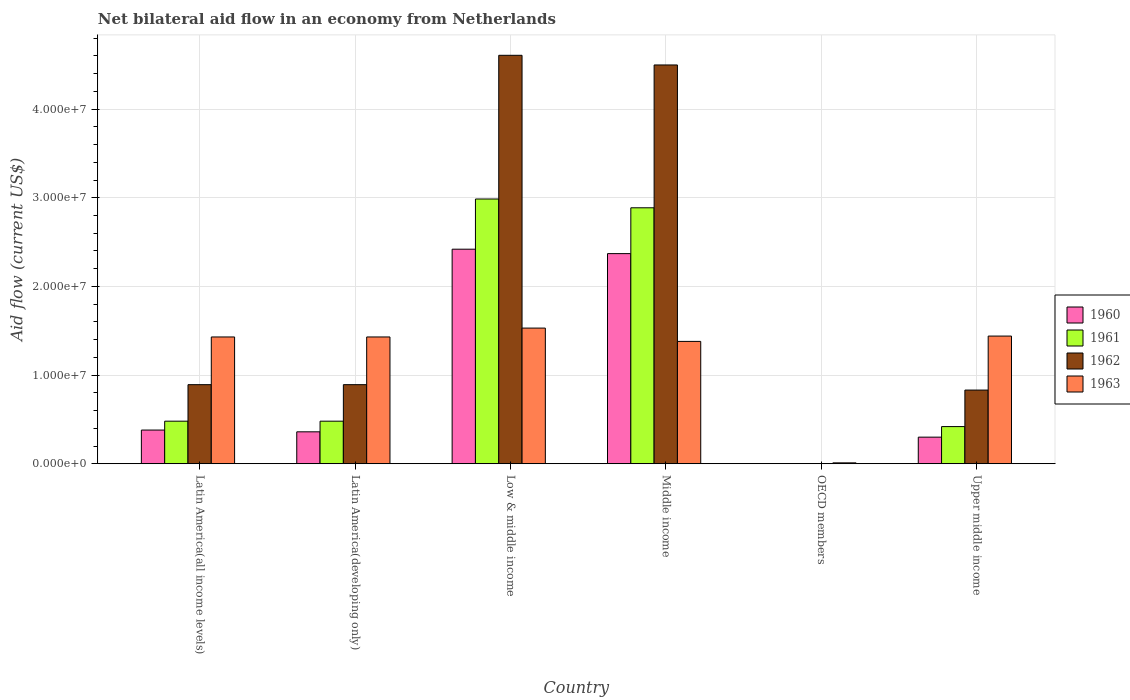Are the number of bars on each tick of the X-axis equal?
Your response must be concise. No. How many bars are there on the 6th tick from the right?
Offer a very short reply. 4. What is the label of the 6th group of bars from the left?
Your answer should be very brief. Upper middle income. What is the net bilateral aid flow in 1963 in Latin America(developing only)?
Your answer should be compact. 1.43e+07. Across all countries, what is the maximum net bilateral aid flow in 1963?
Your response must be concise. 1.53e+07. What is the total net bilateral aid flow in 1962 in the graph?
Offer a very short reply. 1.17e+08. What is the difference between the net bilateral aid flow in 1960 in Latin America(all income levels) and that in Middle income?
Your answer should be compact. -1.99e+07. What is the difference between the net bilateral aid flow in 1961 in Upper middle income and the net bilateral aid flow in 1963 in OECD members?
Provide a succinct answer. 4.09e+06. What is the average net bilateral aid flow in 1961 per country?
Offer a terse response. 1.21e+07. What is the difference between the net bilateral aid flow of/in 1963 and net bilateral aid flow of/in 1961 in Middle income?
Offer a terse response. -1.51e+07. In how many countries, is the net bilateral aid flow in 1963 greater than 16000000 US$?
Ensure brevity in your answer.  0. What is the ratio of the net bilateral aid flow in 1961 in Latin America(all income levels) to that in Upper middle income?
Ensure brevity in your answer.  1.15. What is the difference between the highest and the lowest net bilateral aid flow in 1961?
Provide a succinct answer. 2.99e+07. Is it the case that in every country, the sum of the net bilateral aid flow in 1961 and net bilateral aid flow in 1960 is greater than the net bilateral aid flow in 1963?
Keep it short and to the point. No. Does the graph contain any zero values?
Offer a terse response. Yes. Does the graph contain grids?
Your response must be concise. Yes. Where does the legend appear in the graph?
Your answer should be very brief. Center right. What is the title of the graph?
Make the answer very short. Net bilateral aid flow in an economy from Netherlands. Does "1967" appear as one of the legend labels in the graph?
Provide a succinct answer. No. What is the label or title of the X-axis?
Your answer should be very brief. Country. What is the label or title of the Y-axis?
Provide a succinct answer. Aid flow (current US$). What is the Aid flow (current US$) in 1960 in Latin America(all income levels)?
Give a very brief answer. 3.80e+06. What is the Aid flow (current US$) of 1961 in Latin America(all income levels)?
Give a very brief answer. 4.80e+06. What is the Aid flow (current US$) of 1962 in Latin America(all income levels)?
Make the answer very short. 8.92e+06. What is the Aid flow (current US$) in 1963 in Latin America(all income levels)?
Make the answer very short. 1.43e+07. What is the Aid flow (current US$) in 1960 in Latin America(developing only)?
Provide a short and direct response. 3.60e+06. What is the Aid flow (current US$) of 1961 in Latin America(developing only)?
Your response must be concise. 4.80e+06. What is the Aid flow (current US$) of 1962 in Latin America(developing only)?
Provide a succinct answer. 8.92e+06. What is the Aid flow (current US$) of 1963 in Latin America(developing only)?
Your answer should be very brief. 1.43e+07. What is the Aid flow (current US$) of 1960 in Low & middle income?
Provide a short and direct response. 2.42e+07. What is the Aid flow (current US$) in 1961 in Low & middle income?
Give a very brief answer. 2.99e+07. What is the Aid flow (current US$) of 1962 in Low & middle income?
Your answer should be very brief. 4.61e+07. What is the Aid flow (current US$) in 1963 in Low & middle income?
Your answer should be compact. 1.53e+07. What is the Aid flow (current US$) of 1960 in Middle income?
Make the answer very short. 2.37e+07. What is the Aid flow (current US$) in 1961 in Middle income?
Your response must be concise. 2.89e+07. What is the Aid flow (current US$) in 1962 in Middle income?
Your answer should be compact. 4.50e+07. What is the Aid flow (current US$) in 1963 in Middle income?
Your response must be concise. 1.38e+07. What is the Aid flow (current US$) of 1960 in OECD members?
Your answer should be very brief. 0. What is the Aid flow (current US$) of 1963 in OECD members?
Make the answer very short. 1.00e+05. What is the Aid flow (current US$) in 1960 in Upper middle income?
Keep it short and to the point. 3.00e+06. What is the Aid flow (current US$) of 1961 in Upper middle income?
Make the answer very short. 4.19e+06. What is the Aid flow (current US$) of 1962 in Upper middle income?
Provide a succinct answer. 8.31e+06. What is the Aid flow (current US$) of 1963 in Upper middle income?
Keep it short and to the point. 1.44e+07. Across all countries, what is the maximum Aid flow (current US$) in 1960?
Offer a very short reply. 2.42e+07. Across all countries, what is the maximum Aid flow (current US$) in 1961?
Your answer should be very brief. 2.99e+07. Across all countries, what is the maximum Aid flow (current US$) in 1962?
Ensure brevity in your answer.  4.61e+07. Across all countries, what is the maximum Aid flow (current US$) in 1963?
Your response must be concise. 1.53e+07. Across all countries, what is the minimum Aid flow (current US$) in 1960?
Your answer should be very brief. 0. Across all countries, what is the minimum Aid flow (current US$) of 1961?
Give a very brief answer. 0. Across all countries, what is the minimum Aid flow (current US$) of 1962?
Your response must be concise. 0. Across all countries, what is the minimum Aid flow (current US$) of 1963?
Offer a terse response. 1.00e+05. What is the total Aid flow (current US$) of 1960 in the graph?
Offer a terse response. 5.83e+07. What is the total Aid flow (current US$) in 1961 in the graph?
Keep it short and to the point. 7.25e+07. What is the total Aid flow (current US$) in 1962 in the graph?
Your answer should be very brief. 1.17e+08. What is the total Aid flow (current US$) in 1963 in the graph?
Offer a very short reply. 7.22e+07. What is the difference between the Aid flow (current US$) of 1961 in Latin America(all income levels) and that in Latin America(developing only)?
Provide a short and direct response. 0. What is the difference between the Aid flow (current US$) in 1963 in Latin America(all income levels) and that in Latin America(developing only)?
Offer a very short reply. 0. What is the difference between the Aid flow (current US$) in 1960 in Latin America(all income levels) and that in Low & middle income?
Make the answer very short. -2.04e+07. What is the difference between the Aid flow (current US$) of 1961 in Latin America(all income levels) and that in Low & middle income?
Offer a terse response. -2.51e+07. What is the difference between the Aid flow (current US$) in 1962 in Latin America(all income levels) and that in Low & middle income?
Offer a very short reply. -3.72e+07. What is the difference between the Aid flow (current US$) of 1960 in Latin America(all income levels) and that in Middle income?
Provide a short and direct response. -1.99e+07. What is the difference between the Aid flow (current US$) in 1961 in Latin America(all income levels) and that in Middle income?
Your response must be concise. -2.41e+07. What is the difference between the Aid flow (current US$) of 1962 in Latin America(all income levels) and that in Middle income?
Provide a short and direct response. -3.61e+07. What is the difference between the Aid flow (current US$) in 1963 in Latin America(all income levels) and that in OECD members?
Keep it short and to the point. 1.42e+07. What is the difference between the Aid flow (current US$) of 1963 in Latin America(all income levels) and that in Upper middle income?
Make the answer very short. -1.00e+05. What is the difference between the Aid flow (current US$) in 1960 in Latin America(developing only) and that in Low & middle income?
Give a very brief answer. -2.06e+07. What is the difference between the Aid flow (current US$) in 1961 in Latin America(developing only) and that in Low & middle income?
Provide a short and direct response. -2.51e+07. What is the difference between the Aid flow (current US$) in 1962 in Latin America(developing only) and that in Low & middle income?
Provide a short and direct response. -3.72e+07. What is the difference between the Aid flow (current US$) of 1960 in Latin America(developing only) and that in Middle income?
Your answer should be very brief. -2.01e+07. What is the difference between the Aid flow (current US$) in 1961 in Latin America(developing only) and that in Middle income?
Make the answer very short. -2.41e+07. What is the difference between the Aid flow (current US$) in 1962 in Latin America(developing only) and that in Middle income?
Offer a very short reply. -3.61e+07. What is the difference between the Aid flow (current US$) in 1963 in Latin America(developing only) and that in OECD members?
Make the answer very short. 1.42e+07. What is the difference between the Aid flow (current US$) in 1963 in Latin America(developing only) and that in Upper middle income?
Provide a short and direct response. -1.00e+05. What is the difference between the Aid flow (current US$) in 1961 in Low & middle income and that in Middle income?
Your answer should be compact. 9.90e+05. What is the difference between the Aid flow (current US$) in 1962 in Low & middle income and that in Middle income?
Offer a very short reply. 1.09e+06. What is the difference between the Aid flow (current US$) of 1963 in Low & middle income and that in Middle income?
Offer a terse response. 1.50e+06. What is the difference between the Aid flow (current US$) of 1963 in Low & middle income and that in OECD members?
Ensure brevity in your answer.  1.52e+07. What is the difference between the Aid flow (current US$) of 1960 in Low & middle income and that in Upper middle income?
Provide a succinct answer. 2.12e+07. What is the difference between the Aid flow (current US$) of 1961 in Low & middle income and that in Upper middle income?
Make the answer very short. 2.57e+07. What is the difference between the Aid flow (current US$) in 1962 in Low & middle income and that in Upper middle income?
Make the answer very short. 3.78e+07. What is the difference between the Aid flow (current US$) in 1963 in Low & middle income and that in Upper middle income?
Your answer should be compact. 9.00e+05. What is the difference between the Aid flow (current US$) in 1963 in Middle income and that in OECD members?
Your answer should be very brief. 1.37e+07. What is the difference between the Aid flow (current US$) of 1960 in Middle income and that in Upper middle income?
Ensure brevity in your answer.  2.07e+07. What is the difference between the Aid flow (current US$) in 1961 in Middle income and that in Upper middle income?
Your answer should be compact. 2.47e+07. What is the difference between the Aid flow (current US$) of 1962 in Middle income and that in Upper middle income?
Offer a terse response. 3.67e+07. What is the difference between the Aid flow (current US$) in 1963 in Middle income and that in Upper middle income?
Ensure brevity in your answer.  -6.00e+05. What is the difference between the Aid flow (current US$) of 1963 in OECD members and that in Upper middle income?
Ensure brevity in your answer.  -1.43e+07. What is the difference between the Aid flow (current US$) in 1960 in Latin America(all income levels) and the Aid flow (current US$) in 1961 in Latin America(developing only)?
Give a very brief answer. -1.00e+06. What is the difference between the Aid flow (current US$) in 1960 in Latin America(all income levels) and the Aid flow (current US$) in 1962 in Latin America(developing only)?
Provide a short and direct response. -5.12e+06. What is the difference between the Aid flow (current US$) of 1960 in Latin America(all income levels) and the Aid flow (current US$) of 1963 in Latin America(developing only)?
Ensure brevity in your answer.  -1.05e+07. What is the difference between the Aid flow (current US$) of 1961 in Latin America(all income levels) and the Aid flow (current US$) of 1962 in Latin America(developing only)?
Your answer should be compact. -4.12e+06. What is the difference between the Aid flow (current US$) of 1961 in Latin America(all income levels) and the Aid flow (current US$) of 1963 in Latin America(developing only)?
Your answer should be very brief. -9.50e+06. What is the difference between the Aid flow (current US$) in 1962 in Latin America(all income levels) and the Aid flow (current US$) in 1963 in Latin America(developing only)?
Give a very brief answer. -5.38e+06. What is the difference between the Aid flow (current US$) of 1960 in Latin America(all income levels) and the Aid flow (current US$) of 1961 in Low & middle income?
Give a very brief answer. -2.61e+07. What is the difference between the Aid flow (current US$) in 1960 in Latin America(all income levels) and the Aid flow (current US$) in 1962 in Low & middle income?
Provide a short and direct response. -4.23e+07. What is the difference between the Aid flow (current US$) in 1960 in Latin America(all income levels) and the Aid flow (current US$) in 1963 in Low & middle income?
Provide a succinct answer. -1.15e+07. What is the difference between the Aid flow (current US$) of 1961 in Latin America(all income levels) and the Aid flow (current US$) of 1962 in Low & middle income?
Give a very brief answer. -4.13e+07. What is the difference between the Aid flow (current US$) of 1961 in Latin America(all income levels) and the Aid flow (current US$) of 1963 in Low & middle income?
Provide a short and direct response. -1.05e+07. What is the difference between the Aid flow (current US$) of 1962 in Latin America(all income levels) and the Aid flow (current US$) of 1963 in Low & middle income?
Provide a succinct answer. -6.38e+06. What is the difference between the Aid flow (current US$) of 1960 in Latin America(all income levels) and the Aid flow (current US$) of 1961 in Middle income?
Offer a terse response. -2.51e+07. What is the difference between the Aid flow (current US$) of 1960 in Latin America(all income levels) and the Aid flow (current US$) of 1962 in Middle income?
Offer a terse response. -4.12e+07. What is the difference between the Aid flow (current US$) of 1960 in Latin America(all income levels) and the Aid flow (current US$) of 1963 in Middle income?
Offer a terse response. -1.00e+07. What is the difference between the Aid flow (current US$) in 1961 in Latin America(all income levels) and the Aid flow (current US$) in 1962 in Middle income?
Your response must be concise. -4.02e+07. What is the difference between the Aid flow (current US$) in 1961 in Latin America(all income levels) and the Aid flow (current US$) in 1963 in Middle income?
Provide a succinct answer. -9.00e+06. What is the difference between the Aid flow (current US$) of 1962 in Latin America(all income levels) and the Aid flow (current US$) of 1963 in Middle income?
Keep it short and to the point. -4.88e+06. What is the difference between the Aid flow (current US$) in 1960 in Latin America(all income levels) and the Aid flow (current US$) in 1963 in OECD members?
Offer a terse response. 3.70e+06. What is the difference between the Aid flow (current US$) in 1961 in Latin America(all income levels) and the Aid flow (current US$) in 1963 in OECD members?
Offer a terse response. 4.70e+06. What is the difference between the Aid flow (current US$) in 1962 in Latin America(all income levels) and the Aid flow (current US$) in 1963 in OECD members?
Your response must be concise. 8.82e+06. What is the difference between the Aid flow (current US$) in 1960 in Latin America(all income levels) and the Aid flow (current US$) in 1961 in Upper middle income?
Keep it short and to the point. -3.90e+05. What is the difference between the Aid flow (current US$) of 1960 in Latin America(all income levels) and the Aid flow (current US$) of 1962 in Upper middle income?
Provide a succinct answer. -4.51e+06. What is the difference between the Aid flow (current US$) in 1960 in Latin America(all income levels) and the Aid flow (current US$) in 1963 in Upper middle income?
Your response must be concise. -1.06e+07. What is the difference between the Aid flow (current US$) of 1961 in Latin America(all income levels) and the Aid flow (current US$) of 1962 in Upper middle income?
Your answer should be very brief. -3.51e+06. What is the difference between the Aid flow (current US$) in 1961 in Latin America(all income levels) and the Aid flow (current US$) in 1963 in Upper middle income?
Make the answer very short. -9.60e+06. What is the difference between the Aid flow (current US$) in 1962 in Latin America(all income levels) and the Aid flow (current US$) in 1963 in Upper middle income?
Provide a succinct answer. -5.48e+06. What is the difference between the Aid flow (current US$) in 1960 in Latin America(developing only) and the Aid flow (current US$) in 1961 in Low & middle income?
Ensure brevity in your answer.  -2.63e+07. What is the difference between the Aid flow (current US$) of 1960 in Latin America(developing only) and the Aid flow (current US$) of 1962 in Low & middle income?
Make the answer very short. -4.25e+07. What is the difference between the Aid flow (current US$) in 1960 in Latin America(developing only) and the Aid flow (current US$) in 1963 in Low & middle income?
Offer a very short reply. -1.17e+07. What is the difference between the Aid flow (current US$) in 1961 in Latin America(developing only) and the Aid flow (current US$) in 1962 in Low & middle income?
Offer a very short reply. -4.13e+07. What is the difference between the Aid flow (current US$) of 1961 in Latin America(developing only) and the Aid flow (current US$) of 1963 in Low & middle income?
Ensure brevity in your answer.  -1.05e+07. What is the difference between the Aid flow (current US$) in 1962 in Latin America(developing only) and the Aid flow (current US$) in 1963 in Low & middle income?
Your response must be concise. -6.38e+06. What is the difference between the Aid flow (current US$) of 1960 in Latin America(developing only) and the Aid flow (current US$) of 1961 in Middle income?
Keep it short and to the point. -2.53e+07. What is the difference between the Aid flow (current US$) of 1960 in Latin America(developing only) and the Aid flow (current US$) of 1962 in Middle income?
Ensure brevity in your answer.  -4.14e+07. What is the difference between the Aid flow (current US$) of 1960 in Latin America(developing only) and the Aid flow (current US$) of 1963 in Middle income?
Provide a succinct answer. -1.02e+07. What is the difference between the Aid flow (current US$) in 1961 in Latin America(developing only) and the Aid flow (current US$) in 1962 in Middle income?
Give a very brief answer. -4.02e+07. What is the difference between the Aid flow (current US$) in 1961 in Latin America(developing only) and the Aid flow (current US$) in 1963 in Middle income?
Your response must be concise. -9.00e+06. What is the difference between the Aid flow (current US$) in 1962 in Latin America(developing only) and the Aid flow (current US$) in 1963 in Middle income?
Offer a very short reply. -4.88e+06. What is the difference between the Aid flow (current US$) in 1960 in Latin America(developing only) and the Aid flow (current US$) in 1963 in OECD members?
Your answer should be very brief. 3.50e+06. What is the difference between the Aid flow (current US$) in 1961 in Latin America(developing only) and the Aid flow (current US$) in 1963 in OECD members?
Your answer should be very brief. 4.70e+06. What is the difference between the Aid flow (current US$) of 1962 in Latin America(developing only) and the Aid flow (current US$) of 1963 in OECD members?
Keep it short and to the point. 8.82e+06. What is the difference between the Aid flow (current US$) of 1960 in Latin America(developing only) and the Aid flow (current US$) of 1961 in Upper middle income?
Your answer should be very brief. -5.90e+05. What is the difference between the Aid flow (current US$) of 1960 in Latin America(developing only) and the Aid flow (current US$) of 1962 in Upper middle income?
Provide a succinct answer. -4.71e+06. What is the difference between the Aid flow (current US$) of 1960 in Latin America(developing only) and the Aid flow (current US$) of 1963 in Upper middle income?
Your answer should be compact. -1.08e+07. What is the difference between the Aid flow (current US$) of 1961 in Latin America(developing only) and the Aid flow (current US$) of 1962 in Upper middle income?
Give a very brief answer. -3.51e+06. What is the difference between the Aid flow (current US$) of 1961 in Latin America(developing only) and the Aid flow (current US$) of 1963 in Upper middle income?
Ensure brevity in your answer.  -9.60e+06. What is the difference between the Aid flow (current US$) in 1962 in Latin America(developing only) and the Aid flow (current US$) in 1963 in Upper middle income?
Offer a very short reply. -5.48e+06. What is the difference between the Aid flow (current US$) of 1960 in Low & middle income and the Aid flow (current US$) of 1961 in Middle income?
Make the answer very short. -4.67e+06. What is the difference between the Aid flow (current US$) of 1960 in Low & middle income and the Aid flow (current US$) of 1962 in Middle income?
Make the answer very short. -2.08e+07. What is the difference between the Aid flow (current US$) of 1960 in Low & middle income and the Aid flow (current US$) of 1963 in Middle income?
Provide a short and direct response. 1.04e+07. What is the difference between the Aid flow (current US$) of 1961 in Low & middle income and the Aid flow (current US$) of 1962 in Middle income?
Provide a succinct answer. -1.51e+07. What is the difference between the Aid flow (current US$) in 1961 in Low & middle income and the Aid flow (current US$) in 1963 in Middle income?
Your answer should be very brief. 1.61e+07. What is the difference between the Aid flow (current US$) of 1962 in Low & middle income and the Aid flow (current US$) of 1963 in Middle income?
Make the answer very short. 3.23e+07. What is the difference between the Aid flow (current US$) of 1960 in Low & middle income and the Aid flow (current US$) of 1963 in OECD members?
Provide a succinct answer. 2.41e+07. What is the difference between the Aid flow (current US$) in 1961 in Low & middle income and the Aid flow (current US$) in 1963 in OECD members?
Provide a succinct answer. 2.98e+07. What is the difference between the Aid flow (current US$) in 1962 in Low & middle income and the Aid flow (current US$) in 1963 in OECD members?
Keep it short and to the point. 4.60e+07. What is the difference between the Aid flow (current US$) in 1960 in Low & middle income and the Aid flow (current US$) in 1961 in Upper middle income?
Ensure brevity in your answer.  2.00e+07. What is the difference between the Aid flow (current US$) of 1960 in Low & middle income and the Aid flow (current US$) of 1962 in Upper middle income?
Keep it short and to the point. 1.59e+07. What is the difference between the Aid flow (current US$) of 1960 in Low & middle income and the Aid flow (current US$) of 1963 in Upper middle income?
Offer a terse response. 9.80e+06. What is the difference between the Aid flow (current US$) of 1961 in Low & middle income and the Aid flow (current US$) of 1962 in Upper middle income?
Keep it short and to the point. 2.16e+07. What is the difference between the Aid flow (current US$) in 1961 in Low & middle income and the Aid flow (current US$) in 1963 in Upper middle income?
Your answer should be very brief. 1.55e+07. What is the difference between the Aid flow (current US$) of 1962 in Low & middle income and the Aid flow (current US$) of 1963 in Upper middle income?
Your answer should be compact. 3.17e+07. What is the difference between the Aid flow (current US$) in 1960 in Middle income and the Aid flow (current US$) in 1963 in OECD members?
Offer a very short reply. 2.36e+07. What is the difference between the Aid flow (current US$) of 1961 in Middle income and the Aid flow (current US$) of 1963 in OECD members?
Provide a short and direct response. 2.88e+07. What is the difference between the Aid flow (current US$) of 1962 in Middle income and the Aid flow (current US$) of 1963 in OECD members?
Make the answer very short. 4.49e+07. What is the difference between the Aid flow (current US$) of 1960 in Middle income and the Aid flow (current US$) of 1961 in Upper middle income?
Give a very brief answer. 1.95e+07. What is the difference between the Aid flow (current US$) in 1960 in Middle income and the Aid flow (current US$) in 1962 in Upper middle income?
Provide a short and direct response. 1.54e+07. What is the difference between the Aid flow (current US$) of 1960 in Middle income and the Aid flow (current US$) of 1963 in Upper middle income?
Provide a short and direct response. 9.30e+06. What is the difference between the Aid flow (current US$) in 1961 in Middle income and the Aid flow (current US$) in 1962 in Upper middle income?
Make the answer very short. 2.06e+07. What is the difference between the Aid flow (current US$) of 1961 in Middle income and the Aid flow (current US$) of 1963 in Upper middle income?
Provide a succinct answer. 1.45e+07. What is the difference between the Aid flow (current US$) of 1962 in Middle income and the Aid flow (current US$) of 1963 in Upper middle income?
Offer a very short reply. 3.06e+07. What is the average Aid flow (current US$) of 1960 per country?
Your answer should be very brief. 9.72e+06. What is the average Aid flow (current US$) of 1961 per country?
Your response must be concise. 1.21e+07. What is the average Aid flow (current US$) of 1962 per country?
Give a very brief answer. 1.95e+07. What is the average Aid flow (current US$) in 1963 per country?
Offer a terse response. 1.20e+07. What is the difference between the Aid flow (current US$) in 1960 and Aid flow (current US$) in 1961 in Latin America(all income levels)?
Offer a terse response. -1.00e+06. What is the difference between the Aid flow (current US$) in 1960 and Aid flow (current US$) in 1962 in Latin America(all income levels)?
Provide a short and direct response. -5.12e+06. What is the difference between the Aid flow (current US$) of 1960 and Aid flow (current US$) of 1963 in Latin America(all income levels)?
Your answer should be compact. -1.05e+07. What is the difference between the Aid flow (current US$) in 1961 and Aid flow (current US$) in 1962 in Latin America(all income levels)?
Provide a succinct answer. -4.12e+06. What is the difference between the Aid flow (current US$) in 1961 and Aid flow (current US$) in 1963 in Latin America(all income levels)?
Provide a short and direct response. -9.50e+06. What is the difference between the Aid flow (current US$) of 1962 and Aid flow (current US$) of 1963 in Latin America(all income levels)?
Ensure brevity in your answer.  -5.38e+06. What is the difference between the Aid flow (current US$) of 1960 and Aid flow (current US$) of 1961 in Latin America(developing only)?
Ensure brevity in your answer.  -1.20e+06. What is the difference between the Aid flow (current US$) of 1960 and Aid flow (current US$) of 1962 in Latin America(developing only)?
Offer a very short reply. -5.32e+06. What is the difference between the Aid flow (current US$) in 1960 and Aid flow (current US$) in 1963 in Latin America(developing only)?
Give a very brief answer. -1.07e+07. What is the difference between the Aid flow (current US$) in 1961 and Aid flow (current US$) in 1962 in Latin America(developing only)?
Ensure brevity in your answer.  -4.12e+06. What is the difference between the Aid flow (current US$) in 1961 and Aid flow (current US$) in 1963 in Latin America(developing only)?
Offer a terse response. -9.50e+06. What is the difference between the Aid flow (current US$) of 1962 and Aid flow (current US$) of 1963 in Latin America(developing only)?
Offer a very short reply. -5.38e+06. What is the difference between the Aid flow (current US$) in 1960 and Aid flow (current US$) in 1961 in Low & middle income?
Ensure brevity in your answer.  -5.66e+06. What is the difference between the Aid flow (current US$) in 1960 and Aid flow (current US$) in 1962 in Low & middle income?
Your answer should be compact. -2.19e+07. What is the difference between the Aid flow (current US$) in 1960 and Aid flow (current US$) in 1963 in Low & middle income?
Make the answer very short. 8.90e+06. What is the difference between the Aid flow (current US$) in 1961 and Aid flow (current US$) in 1962 in Low & middle income?
Your answer should be very brief. -1.62e+07. What is the difference between the Aid flow (current US$) in 1961 and Aid flow (current US$) in 1963 in Low & middle income?
Your answer should be very brief. 1.46e+07. What is the difference between the Aid flow (current US$) of 1962 and Aid flow (current US$) of 1963 in Low & middle income?
Ensure brevity in your answer.  3.08e+07. What is the difference between the Aid flow (current US$) of 1960 and Aid flow (current US$) of 1961 in Middle income?
Offer a terse response. -5.17e+06. What is the difference between the Aid flow (current US$) of 1960 and Aid flow (current US$) of 1962 in Middle income?
Your answer should be compact. -2.13e+07. What is the difference between the Aid flow (current US$) in 1960 and Aid flow (current US$) in 1963 in Middle income?
Your answer should be very brief. 9.90e+06. What is the difference between the Aid flow (current US$) in 1961 and Aid flow (current US$) in 1962 in Middle income?
Provide a succinct answer. -1.61e+07. What is the difference between the Aid flow (current US$) of 1961 and Aid flow (current US$) of 1963 in Middle income?
Offer a terse response. 1.51e+07. What is the difference between the Aid flow (current US$) in 1962 and Aid flow (current US$) in 1963 in Middle income?
Your answer should be compact. 3.12e+07. What is the difference between the Aid flow (current US$) in 1960 and Aid flow (current US$) in 1961 in Upper middle income?
Offer a terse response. -1.19e+06. What is the difference between the Aid flow (current US$) in 1960 and Aid flow (current US$) in 1962 in Upper middle income?
Keep it short and to the point. -5.31e+06. What is the difference between the Aid flow (current US$) of 1960 and Aid flow (current US$) of 1963 in Upper middle income?
Provide a short and direct response. -1.14e+07. What is the difference between the Aid flow (current US$) of 1961 and Aid flow (current US$) of 1962 in Upper middle income?
Offer a very short reply. -4.12e+06. What is the difference between the Aid flow (current US$) in 1961 and Aid flow (current US$) in 1963 in Upper middle income?
Offer a very short reply. -1.02e+07. What is the difference between the Aid flow (current US$) of 1962 and Aid flow (current US$) of 1963 in Upper middle income?
Offer a very short reply. -6.09e+06. What is the ratio of the Aid flow (current US$) of 1960 in Latin America(all income levels) to that in Latin America(developing only)?
Your answer should be compact. 1.06. What is the ratio of the Aid flow (current US$) in 1961 in Latin America(all income levels) to that in Latin America(developing only)?
Provide a short and direct response. 1. What is the ratio of the Aid flow (current US$) in 1962 in Latin America(all income levels) to that in Latin America(developing only)?
Your response must be concise. 1. What is the ratio of the Aid flow (current US$) of 1960 in Latin America(all income levels) to that in Low & middle income?
Give a very brief answer. 0.16. What is the ratio of the Aid flow (current US$) in 1961 in Latin America(all income levels) to that in Low & middle income?
Keep it short and to the point. 0.16. What is the ratio of the Aid flow (current US$) of 1962 in Latin America(all income levels) to that in Low & middle income?
Your response must be concise. 0.19. What is the ratio of the Aid flow (current US$) in 1963 in Latin America(all income levels) to that in Low & middle income?
Offer a very short reply. 0.93. What is the ratio of the Aid flow (current US$) in 1960 in Latin America(all income levels) to that in Middle income?
Provide a short and direct response. 0.16. What is the ratio of the Aid flow (current US$) in 1961 in Latin America(all income levels) to that in Middle income?
Your answer should be very brief. 0.17. What is the ratio of the Aid flow (current US$) of 1962 in Latin America(all income levels) to that in Middle income?
Make the answer very short. 0.2. What is the ratio of the Aid flow (current US$) in 1963 in Latin America(all income levels) to that in Middle income?
Give a very brief answer. 1.04. What is the ratio of the Aid flow (current US$) in 1963 in Latin America(all income levels) to that in OECD members?
Provide a succinct answer. 143. What is the ratio of the Aid flow (current US$) in 1960 in Latin America(all income levels) to that in Upper middle income?
Offer a very short reply. 1.27. What is the ratio of the Aid flow (current US$) of 1961 in Latin America(all income levels) to that in Upper middle income?
Give a very brief answer. 1.15. What is the ratio of the Aid flow (current US$) of 1962 in Latin America(all income levels) to that in Upper middle income?
Your answer should be very brief. 1.07. What is the ratio of the Aid flow (current US$) in 1963 in Latin America(all income levels) to that in Upper middle income?
Offer a terse response. 0.99. What is the ratio of the Aid flow (current US$) of 1960 in Latin America(developing only) to that in Low & middle income?
Make the answer very short. 0.15. What is the ratio of the Aid flow (current US$) in 1961 in Latin America(developing only) to that in Low & middle income?
Your response must be concise. 0.16. What is the ratio of the Aid flow (current US$) in 1962 in Latin America(developing only) to that in Low & middle income?
Ensure brevity in your answer.  0.19. What is the ratio of the Aid flow (current US$) of 1963 in Latin America(developing only) to that in Low & middle income?
Ensure brevity in your answer.  0.93. What is the ratio of the Aid flow (current US$) in 1960 in Latin America(developing only) to that in Middle income?
Provide a succinct answer. 0.15. What is the ratio of the Aid flow (current US$) in 1961 in Latin America(developing only) to that in Middle income?
Offer a terse response. 0.17. What is the ratio of the Aid flow (current US$) of 1962 in Latin America(developing only) to that in Middle income?
Offer a terse response. 0.2. What is the ratio of the Aid flow (current US$) of 1963 in Latin America(developing only) to that in Middle income?
Keep it short and to the point. 1.04. What is the ratio of the Aid flow (current US$) in 1963 in Latin America(developing only) to that in OECD members?
Give a very brief answer. 143. What is the ratio of the Aid flow (current US$) in 1960 in Latin America(developing only) to that in Upper middle income?
Provide a short and direct response. 1.2. What is the ratio of the Aid flow (current US$) of 1961 in Latin America(developing only) to that in Upper middle income?
Offer a terse response. 1.15. What is the ratio of the Aid flow (current US$) in 1962 in Latin America(developing only) to that in Upper middle income?
Ensure brevity in your answer.  1.07. What is the ratio of the Aid flow (current US$) of 1960 in Low & middle income to that in Middle income?
Keep it short and to the point. 1.02. What is the ratio of the Aid flow (current US$) in 1961 in Low & middle income to that in Middle income?
Your response must be concise. 1.03. What is the ratio of the Aid flow (current US$) of 1962 in Low & middle income to that in Middle income?
Keep it short and to the point. 1.02. What is the ratio of the Aid flow (current US$) of 1963 in Low & middle income to that in Middle income?
Make the answer very short. 1.11. What is the ratio of the Aid flow (current US$) of 1963 in Low & middle income to that in OECD members?
Keep it short and to the point. 153. What is the ratio of the Aid flow (current US$) in 1960 in Low & middle income to that in Upper middle income?
Ensure brevity in your answer.  8.07. What is the ratio of the Aid flow (current US$) in 1961 in Low & middle income to that in Upper middle income?
Your answer should be compact. 7.13. What is the ratio of the Aid flow (current US$) in 1962 in Low & middle income to that in Upper middle income?
Give a very brief answer. 5.54. What is the ratio of the Aid flow (current US$) in 1963 in Low & middle income to that in Upper middle income?
Your answer should be compact. 1.06. What is the ratio of the Aid flow (current US$) of 1963 in Middle income to that in OECD members?
Offer a terse response. 138. What is the ratio of the Aid flow (current US$) of 1960 in Middle income to that in Upper middle income?
Keep it short and to the point. 7.9. What is the ratio of the Aid flow (current US$) of 1961 in Middle income to that in Upper middle income?
Your answer should be very brief. 6.89. What is the ratio of the Aid flow (current US$) in 1962 in Middle income to that in Upper middle income?
Your answer should be compact. 5.41. What is the ratio of the Aid flow (current US$) of 1963 in OECD members to that in Upper middle income?
Provide a succinct answer. 0.01. What is the difference between the highest and the second highest Aid flow (current US$) in 1961?
Give a very brief answer. 9.90e+05. What is the difference between the highest and the second highest Aid flow (current US$) in 1962?
Your answer should be compact. 1.09e+06. What is the difference between the highest and the lowest Aid flow (current US$) of 1960?
Provide a short and direct response. 2.42e+07. What is the difference between the highest and the lowest Aid flow (current US$) in 1961?
Your response must be concise. 2.99e+07. What is the difference between the highest and the lowest Aid flow (current US$) in 1962?
Provide a succinct answer. 4.61e+07. What is the difference between the highest and the lowest Aid flow (current US$) in 1963?
Ensure brevity in your answer.  1.52e+07. 